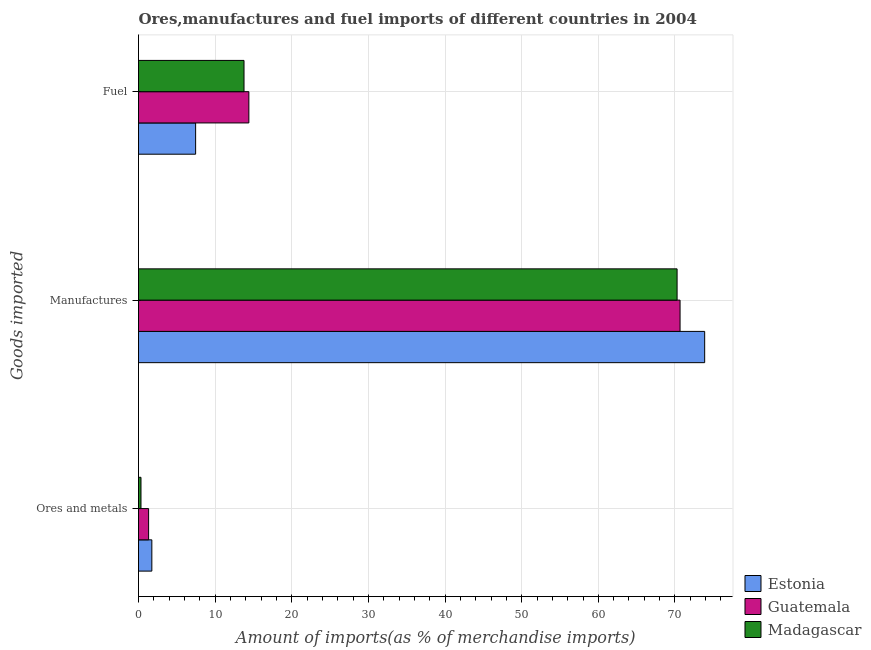How many groups of bars are there?
Keep it short and to the point. 3. How many bars are there on the 1st tick from the top?
Offer a very short reply. 3. What is the label of the 1st group of bars from the top?
Offer a terse response. Fuel. What is the percentage of ores and metals imports in Estonia?
Offer a very short reply. 1.74. Across all countries, what is the maximum percentage of manufactures imports?
Offer a terse response. 73.88. Across all countries, what is the minimum percentage of manufactures imports?
Your answer should be very brief. 70.28. In which country was the percentage of fuel imports maximum?
Provide a succinct answer. Guatemala. In which country was the percentage of ores and metals imports minimum?
Give a very brief answer. Madagascar. What is the total percentage of ores and metals imports in the graph?
Provide a succinct answer. 3.38. What is the difference between the percentage of fuel imports in Estonia and that in Guatemala?
Provide a short and direct response. -6.95. What is the difference between the percentage of fuel imports in Madagascar and the percentage of ores and metals imports in Guatemala?
Your answer should be compact. 12.45. What is the average percentage of manufactures imports per country?
Offer a very short reply. 71.61. What is the difference between the percentage of ores and metals imports and percentage of fuel imports in Estonia?
Make the answer very short. -5.71. What is the ratio of the percentage of ores and metals imports in Guatemala to that in Estonia?
Give a very brief answer. 0.76. Is the difference between the percentage of manufactures imports in Guatemala and Madagascar greater than the difference between the percentage of ores and metals imports in Guatemala and Madagascar?
Provide a short and direct response. No. What is the difference between the highest and the second highest percentage of fuel imports?
Make the answer very short. 0.63. What is the difference between the highest and the lowest percentage of fuel imports?
Your answer should be very brief. 6.95. What does the 2nd bar from the top in Fuel represents?
Provide a succinct answer. Guatemala. What does the 2nd bar from the bottom in Ores and metals represents?
Keep it short and to the point. Guatemala. How many bars are there?
Ensure brevity in your answer.  9. Are all the bars in the graph horizontal?
Ensure brevity in your answer.  Yes. How many countries are there in the graph?
Your answer should be very brief. 3. What is the difference between two consecutive major ticks on the X-axis?
Provide a succinct answer. 10. Does the graph contain grids?
Offer a terse response. Yes. Where does the legend appear in the graph?
Offer a terse response. Bottom right. What is the title of the graph?
Make the answer very short. Ores,manufactures and fuel imports of different countries in 2004. What is the label or title of the X-axis?
Offer a very short reply. Amount of imports(as % of merchandise imports). What is the label or title of the Y-axis?
Your response must be concise. Goods imported. What is the Amount of imports(as % of merchandise imports) in Estonia in Ores and metals?
Offer a very short reply. 1.74. What is the Amount of imports(as % of merchandise imports) of Guatemala in Ores and metals?
Provide a short and direct response. 1.32. What is the Amount of imports(as % of merchandise imports) in Madagascar in Ores and metals?
Ensure brevity in your answer.  0.32. What is the Amount of imports(as % of merchandise imports) of Estonia in Manufactures?
Your answer should be compact. 73.88. What is the Amount of imports(as % of merchandise imports) of Guatemala in Manufactures?
Provide a short and direct response. 70.67. What is the Amount of imports(as % of merchandise imports) of Madagascar in Manufactures?
Make the answer very short. 70.28. What is the Amount of imports(as % of merchandise imports) in Estonia in Fuel?
Ensure brevity in your answer.  7.45. What is the Amount of imports(as % of merchandise imports) of Guatemala in Fuel?
Keep it short and to the point. 14.4. What is the Amount of imports(as % of merchandise imports) of Madagascar in Fuel?
Offer a terse response. 13.77. Across all Goods imported, what is the maximum Amount of imports(as % of merchandise imports) in Estonia?
Your answer should be very brief. 73.88. Across all Goods imported, what is the maximum Amount of imports(as % of merchandise imports) of Guatemala?
Provide a succinct answer. 70.67. Across all Goods imported, what is the maximum Amount of imports(as % of merchandise imports) of Madagascar?
Ensure brevity in your answer.  70.28. Across all Goods imported, what is the minimum Amount of imports(as % of merchandise imports) in Estonia?
Provide a short and direct response. 1.74. Across all Goods imported, what is the minimum Amount of imports(as % of merchandise imports) in Guatemala?
Offer a very short reply. 1.32. Across all Goods imported, what is the minimum Amount of imports(as % of merchandise imports) in Madagascar?
Keep it short and to the point. 0.32. What is the total Amount of imports(as % of merchandise imports) of Estonia in the graph?
Give a very brief answer. 83.07. What is the total Amount of imports(as % of merchandise imports) in Guatemala in the graph?
Provide a short and direct response. 86.38. What is the total Amount of imports(as % of merchandise imports) in Madagascar in the graph?
Make the answer very short. 84.37. What is the difference between the Amount of imports(as % of merchandise imports) of Estonia in Ores and metals and that in Manufactures?
Provide a short and direct response. -72.14. What is the difference between the Amount of imports(as % of merchandise imports) of Guatemala in Ores and metals and that in Manufactures?
Make the answer very short. -69.35. What is the difference between the Amount of imports(as % of merchandise imports) of Madagascar in Ores and metals and that in Manufactures?
Your answer should be compact. -69.95. What is the difference between the Amount of imports(as % of merchandise imports) of Estonia in Ores and metals and that in Fuel?
Keep it short and to the point. -5.71. What is the difference between the Amount of imports(as % of merchandise imports) of Guatemala in Ores and metals and that in Fuel?
Provide a succinct answer. -13.08. What is the difference between the Amount of imports(as % of merchandise imports) in Madagascar in Ores and metals and that in Fuel?
Offer a very short reply. -13.44. What is the difference between the Amount of imports(as % of merchandise imports) in Estonia in Manufactures and that in Fuel?
Make the answer very short. 66.42. What is the difference between the Amount of imports(as % of merchandise imports) of Guatemala in Manufactures and that in Fuel?
Offer a terse response. 56.27. What is the difference between the Amount of imports(as % of merchandise imports) of Madagascar in Manufactures and that in Fuel?
Keep it short and to the point. 56.51. What is the difference between the Amount of imports(as % of merchandise imports) in Estonia in Ores and metals and the Amount of imports(as % of merchandise imports) in Guatemala in Manufactures?
Make the answer very short. -68.93. What is the difference between the Amount of imports(as % of merchandise imports) of Estonia in Ores and metals and the Amount of imports(as % of merchandise imports) of Madagascar in Manufactures?
Ensure brevity in your answer.  -68.54. What is the difference between the Amount of imports(as % of merchandise imports) in Guatemala in Ores and metals and the Amount of imports(as % of merchandise imports) in Madagascar in Manufactures?
Your response must be concise. -68.96. What is the difference between the Amount of imports(as % of merchandise imports) of Estonia in Ores and metals and the Amount of imports(as % of merchandise imports) of Guatemala in Fuel?
Provide a short and direct response. -12.66. What is the difference between the Amount of imports(as % of merchandise imports) in Estonia in Ores and metals and the Amount of imports(as % of merchandise imports) in Madagascar in Fuel?
Give a very brief answer. -12.03. What is the difference between the Amount of imports(as % of merchandise imports) of Guatemala in Ores and metals and the Amount of imports(as % of merchandise imports) of Madagascar in Fuel?
Provide a short and direct response. -12.45. What is the difference between the Amount of imports(as % of merchandise imports) in Estonia in Manufactures and the Amount of imports(as % of merchandise imports) in Guatemala in Fuel?
Offer a terse response. 59.48. What is the difference between the Amount of imports(as % of merchandise imports) in Estonia in Manufactures and the Amount of imports(as % of merchandise imports) in Madagascar in Fuel?
Ensure brevity in your answer.  60.11. What is the difference between the Amount of imports(as % of merchandise imports) of Guatemala in Manufactures and the Amount of imports(as % of merchandise imports) of Madagascar in Fuel?
Provide a short and direct response. 56.9. What is the average Amount of imports(as % of merchandise imports) in Estonia per Goods imported?
Your answer should be very brief. 27.69. What is the average Amount of imports(as % of merchandise imports) in Guatemala per Goods imported?
Your answer should be compact. 28.79. What is the average Amount of imports(as % of merchandise imports) of Madagascar per Goods imported?
Your answer should be compact. 28.12. What is the difference between the Amount of imports(as % of merchandise imports) of Estonia and Amount of imports(as % of merchandise imports) of Guatemala in Ores and metals?
Provide a succinct answer. 0.42. What is the difference between the Amount of imports(as % of merchandise imports) in Estonia and Amount of imports(as % of merchandise imports) in Madagascar in Ores and metals?
Give a very brief answer. 1.42. What is the difference between the Amount of imports(as % of merchandise imports) of Estonia and Amount of imports(as % of merchandise imports) of Guatemala in Manufactures?
Ensure brevity in your answer.  3.21. What is the difference between the Amount of imports(as % of merchandise imports) of Estonia and Amount of imports(as % of merchandise imports) of Madagascar in Manufactures?
Ensure brevity in your answer.  3.6. What is the difference between the Amount of imports(as % of merchandise imports) of Guatemala and Amount of imports(as % of merchandise imports) of Madagascar in Manufactures?
Your answer should be compact. 0.39. What is the difference between the Amount of imports(as % of merchandise imports) of Estonia and Amount of imports(as % of merchandise imports) of Guatemala in Fuel?
Your answer should be compact. -6.95. What is the difference between the Amount of imports(as % of merchandise imports) in Estonia and Amount of imports(as % of merchandise imports) in Madagascar in Fuel?
Offer a terse response. -6.32. What is the difference between the Amount of imports(as % of merchandise imports) in Guatemala and Amount of imports(as % of merchandise imports) in Madagascar in Fuel?
Offer a very short reply. 0.63. What is the ratio of the Amount of imports(as % of merchandise imports) in Estonia in Ores and metals to that in Manufactures?
Provide a succinct answer. 0.02. What is the ratio of the Amount of imports(as % of merchandise imports) of Guatemala in Ores and metals to that in Manufactures?
Provide a short and direct response. 0.02. What is the ratio of the Amount of imports(as % of merchandise imports) of Madagascar in Ores and metals to that in Manufactures?
Ensure brevity in your answer.  0. What is the ratio of the Amount of imports(as % of merchandise imports) in Estonia in Ores and metals to that in Fuel?
Make the answer very short. 0.23. What is the ratio of the Amount of imports(as % of merchandise imports) of Guatemala in Ores and metals to that in Fuel?
Provide a short and direct response. 0.09. What is the ratio of the Amount of imports(as % of merchandise imports) in Madagascar in Ores and metals to that in Fuel?
Your answer should be very brief. 0.02. What is the ratio of the Amount of imports(as % of merchandise imports) of Estonia in Manufactures to that in Fuel?
Offer a very short reply. 9.91. What is the ratio of the Amount of imports(as % of merchandise imports) in Guatemala in Manufactures to that in Fuel?
Give a very brief answer. 4.91. What is the ratio of the Amount of imports(as % of merchandise imports) of Madagascar in Manufactures to that in Fuel?
Keep it short and to the point. 5.1. What is the difference between the highest and the second highest Amount of imports(as % of merchandise imports) in Estonia?
Provide a short and direct response. 66.42. What is the difference between the highest and the second highest Amount of imports(as % of merchandise imports) of Guatemala?
Your answer should be very brief. 56.27. What is the difference between the highest and the second highest Amount of imports(as % of merchandise imports) of Madagascar?
Your answer should be very brief. 56.51. What is the difference between the highest and the lowest Amount of imports(as % of merchandise imports) of Estonia?
Give a very brief answer. 72.14. What is the difference between the highest and the lowest Amount of imports(as % of merchandise imports) of Guatemala?
Your response must be concise. 69.35. What is the difference between the highest and the lowest Amount of imports(as % of merchandise imports) in Madagascar?
Ensure brevity in your answer.  69.95. 